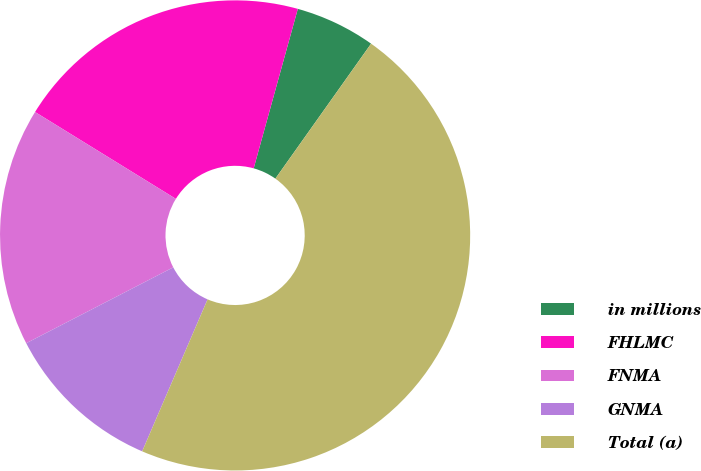Convert chart to OTSL. <chart><loc_0><loc_0><loc_500><loc_500><pie_chart><fcel>in millions<fcel>FHLMC<fcel>FNMA<fcel>GNMA<fcel>Total (a)<nl><fcel>5.52%<fcel>20.5%<fcel>16.38%<fcel>10.95%<fcel>46.65%<nl></chart> 